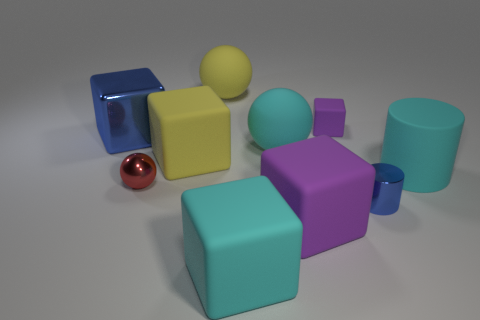What color is the big block that is on the right side of the red ball and behind the large purple matte block?
Give a very brief answer. Yellow. There is a red metallic thing that is the same size as the blue shiny cylinder; what is its shape?
Your answer should be compact. Sphere. Are there any big purple matte objects that have the same shape as the big blue shiny thing?
Offer a terse response. Yes. Does the blue cylinder have the same material as the big thing to the right of the blue metal cylinder?
Your answer should be compact. No. There is a large object that is behind the thing left of the small metal object that is to the left of the small blue cylinder; what is its color?
Offer a very short reply. Yellow. What is the material of the purple thing that is the same size as the blue cylinder?
Provide a succinct answer. Rubber. How many large blue blocks have the same material as the small red thing?
Offer a very short reply. 1. Do the yellow cube to the left of the large purple matte thing and the cyan object that is on the right side of the small blue metal cylinder have the same size?
Your answer should be very brief. Yes. There is a tiny rubber thing that is on the right side of the large yellow cube; what is its color?
Provide a succinct answer. Purple. There is a big block that is the same color as the small cylinder; what is its material?
Your answer should be very brief. Metal. 